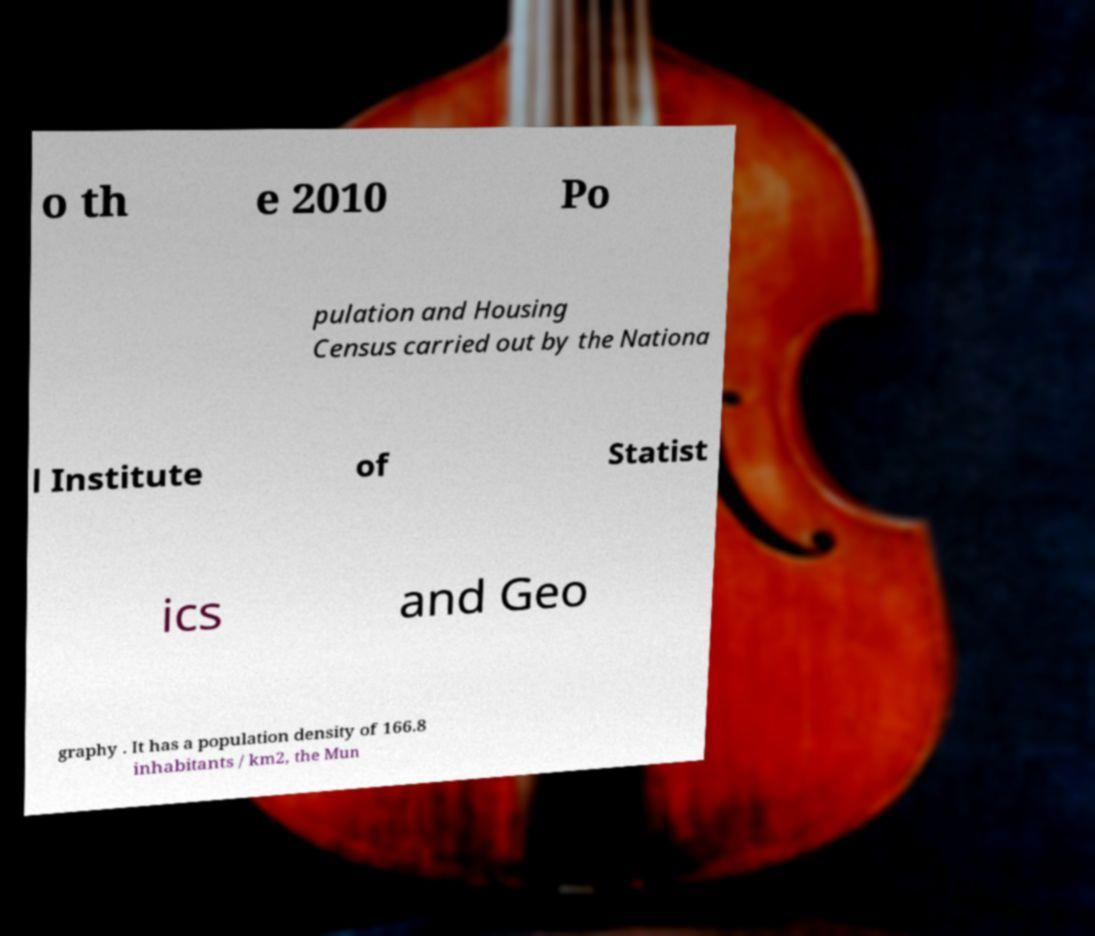There's text embedded in this image that I need extracted. Can you transcribe it verbatim? o th e 2010 Po pulation and Housing Census carried out by the Nationa l Institute of Statist ics and Geo graphy . It has a population density of 166.8 inhabitants / km2, the Mun 